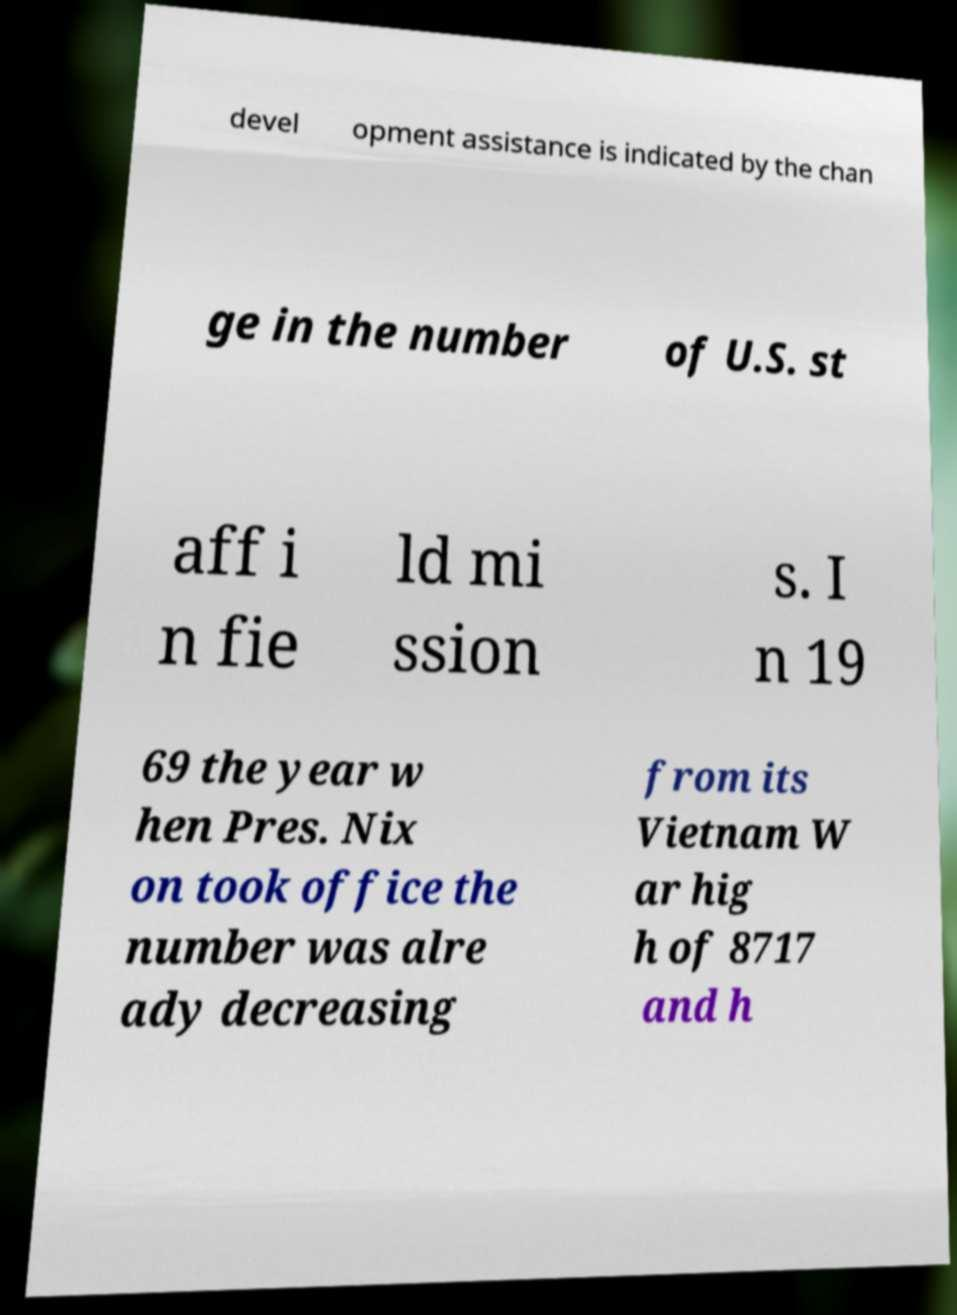Can you read and provide the text displayed in the image?This photo seems to have some interesting text. Can you extract and type it out for me? devel opment assistance is indicated by the chan ge in the number of U.S. st aff i n fie ld mi ssion s. I n 19 69 the year w hen Pres. Nix on took office the number was alre ady decreasing from its Vietnam W ar hig h of 8717 and h 